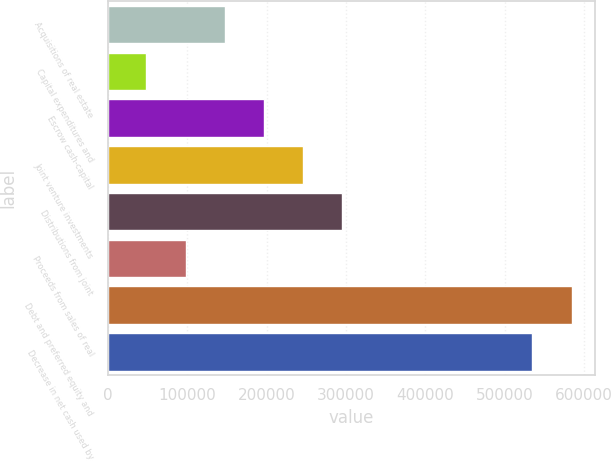Convert chart to OTSL. <chart><loc_0><loc_0><loc_500><loc_500><bar_chart><fcel>Acquisitions of real estate<fcel>Capital expenditures and<fcel>Escrow cash-capital<fcel>Joint venture investments<fcel>Distributions from joint<fcel>Proceeds from sales of real<fcel>Debt and preferred equity and<fcel>Decrease in net cash used by<nl><fcel>147166<fcel>48423<fcel>196537<fcel>245908<fcel>295280<fcel>97794.3<fcel>584339<fcel>534968<nl></chart> 